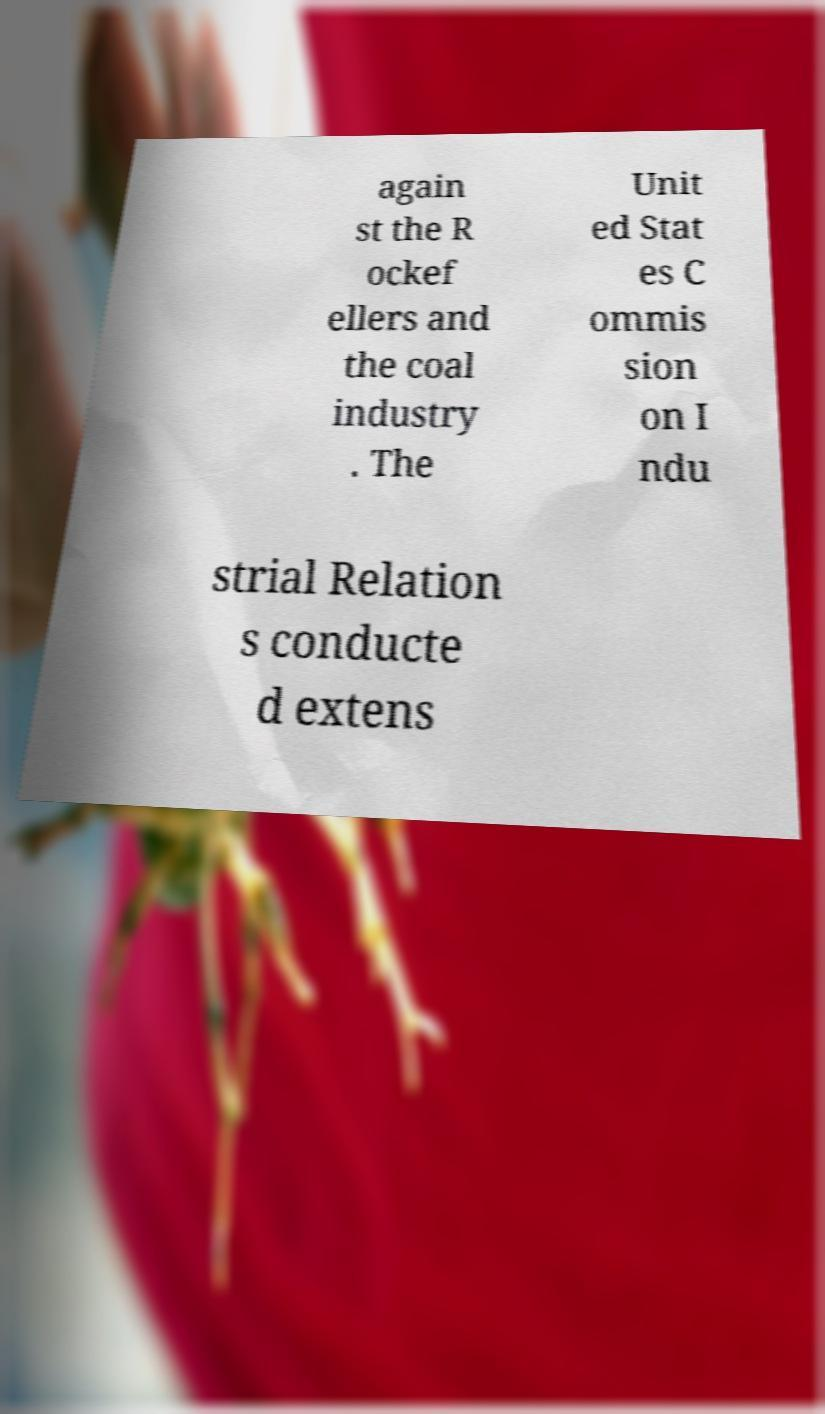Please identify and transcribe the text found in this image. again st the R ockef ellers and the coal industry . The Unit ed Stat es C ommis sion on I ndu strial Relation s conducte d extens 